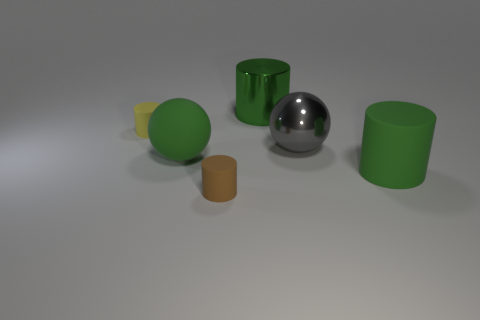Is the green metallic thing the same size as the brown matte object?
Provide a succinct answer. No. There is a metallic thing that is the same color as the rubber ball; what shape is it?
Offer a terse response. Cylinder. Does the green matte cylinder have the same size as the green object that is to the left of the brown matte cylinder?
Ensure brevity in your answer.  Yes. There is a big thing that is both right of the green shiny cylinder and behind the large rubber cylinder; what is its color?
Provide a succinct answer. Gray. Is the number of large green cylinders that are behind the green ball greater than the number of green cylinders in front of the large gray metallic sphere?
Your answer should be very brief. No. The green cylinder that is the same material as the yellow object is what size?
Keep it short and to the point. Large. What number of cylinders are on the left side of the tiny thing that is in front of the green sphere?
Keep it short and to the point. 1. Are there any gray metal objects that have the same shape as the tiny yellow matte thing?
Offer a very short reply. No. There is a thing in front of the big green cylinder right of the large metal cylinder; what color is it?
Make the answer very short. Brown. Is the number of balls greater than the number of blue metallic cylinders?
Make the answer very short. Yes. 